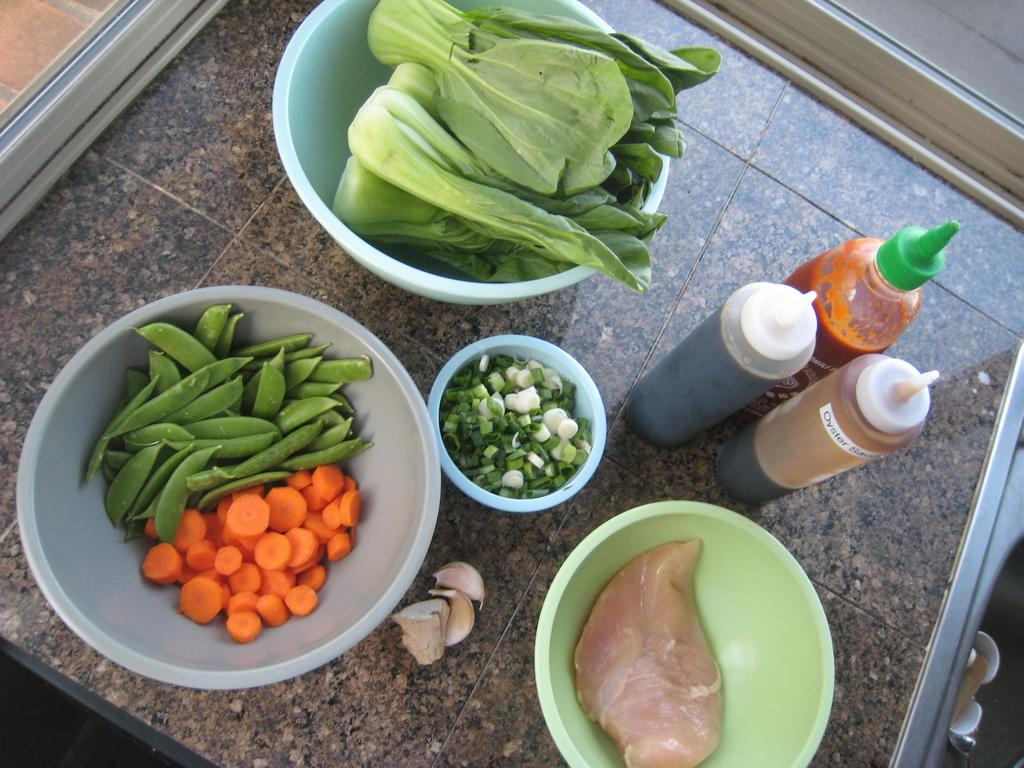What type of containers are present in the image? There are bowls in the image. What other items can be seen in the image? There are bottles, garlic, and ginger in the image. What is inside the bowls? The bowls contain green peas, green leaves, meat, and pieces of carrot. Can you tell me how many firemen are present in the image? There are no firemen present in the image. What type of shoes can be seen on the feet of the people in the image? There are no people or feet visible in the image. 